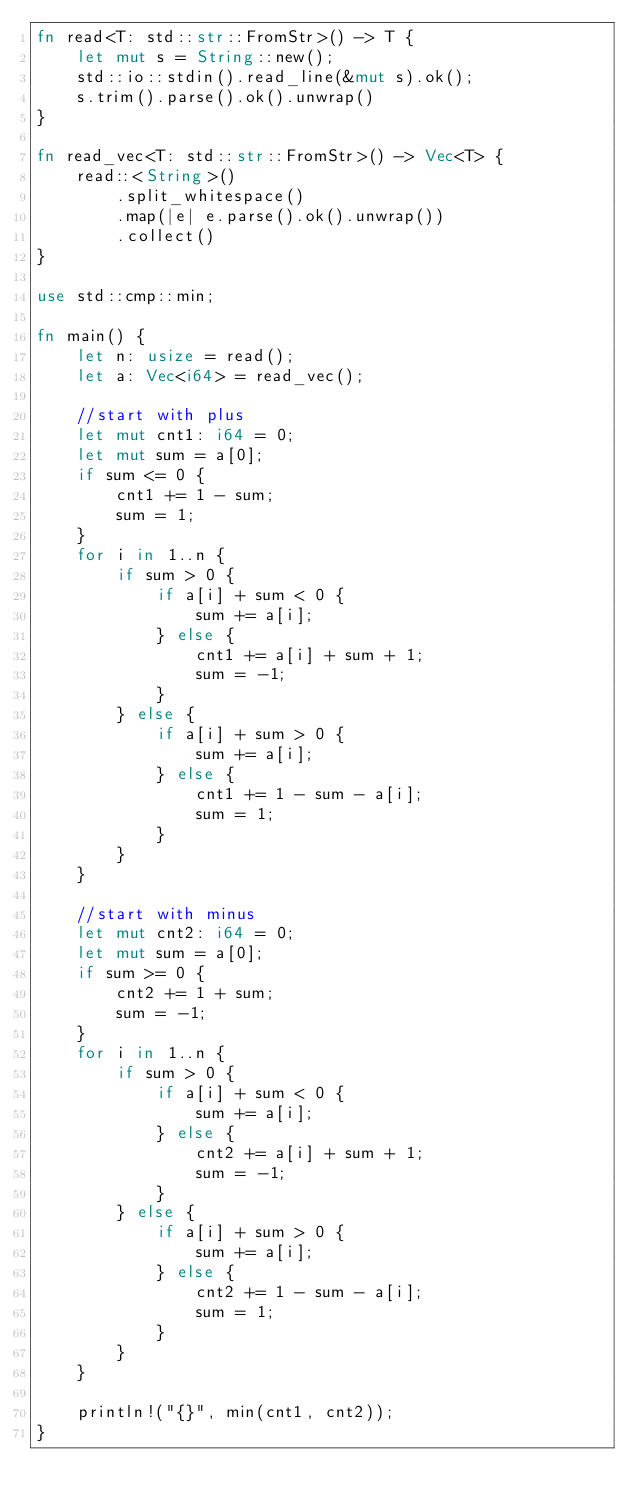Convert code to text. <code><loc_0><loc_0><loc_500><loc_500><_Rust_>fn read<T: std::str::FromStr>() -> T {
    let mut s = String::new();
    std::io::stdin().read_line(&mut s).ok();
    s.trim().parse().ok().unwrap()
}

fn read_vec<T: std::str::FromStr>() -> Vec<T> {
    read::<String>()
        .split_whitespace()
        .map(|e| e.parse().ok().unwrap())
        .collect()
}

use std::cmp::min;

fn main() {
    let n: usize = read();
    let a: Vec<i64> = read_vec();

    //start with plus
    let mut cnt1: i64 = 0;
    let mut sum = a[0];
    if sum <= 0 {
        cnt1 += 1 - sum;
        sum = 1;
    }
    for i in 1..n {
        if sum > 0 {
            if a[i] + sum < 0 {
                sum += a[i];
            } else {
                cnt1 += a[i] + sum + 1;
                sum = -1;
            }
        } else {
            if a[i] + sum > 0 {
                sum += a[i];
            } else {
                cnt1 += 1 - sum - a[i];
                sum = 1;
            }
        }
    }

    //start with minus
    let mut cnt2: i64 = 0;
    let mut sum = a[0];
    if sum >= 0 {
        cnt2 += 1 + sum;
        sum = -1;
    }
    for i in 1..n {
        if sum > 0 {
            if a[i] + sum < 0 {
                sum += a[i];
            } else {
                cnt2 += a[i] + sum + 1;
                sum = -1;
            }
        } else {
            if a[i] + sum > 0 {
                sum += a[i];
            } else {
                cnt2 += 1 - sum - a[i];
                sum = 1;
            }
        }
    }

    println!("{}", min(cnt1, cnt2));
}
</code> 